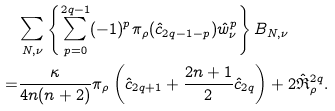Convert formula to latex. <formula><loc_0><loc_0><loc_500><loc_500>& \sum _ { N , \nu } \left \{ \sum _ { p = 0 } ^ { 2 q - 1 } ( - 1 ) ^ { p } \pi _ { \rho } ( \hat { c } _ { 2 q - 1 - p } ) \hat { w } _ { \nu } ^ { p } \right \} B _ { N , \nu } \\ = & \frac { \kappa } { 4 n ( n + 2 ) } \pi _ { \rho } \left ( \hat { c } _ { 2 q + 1 } + \frac { 2 n + 1 } { 2 } \hat { c } _ { 2 q } \right ) + 2 \hat { \mathfrak { R } } ^ { 2 q } _ { \rho } .</formula> 